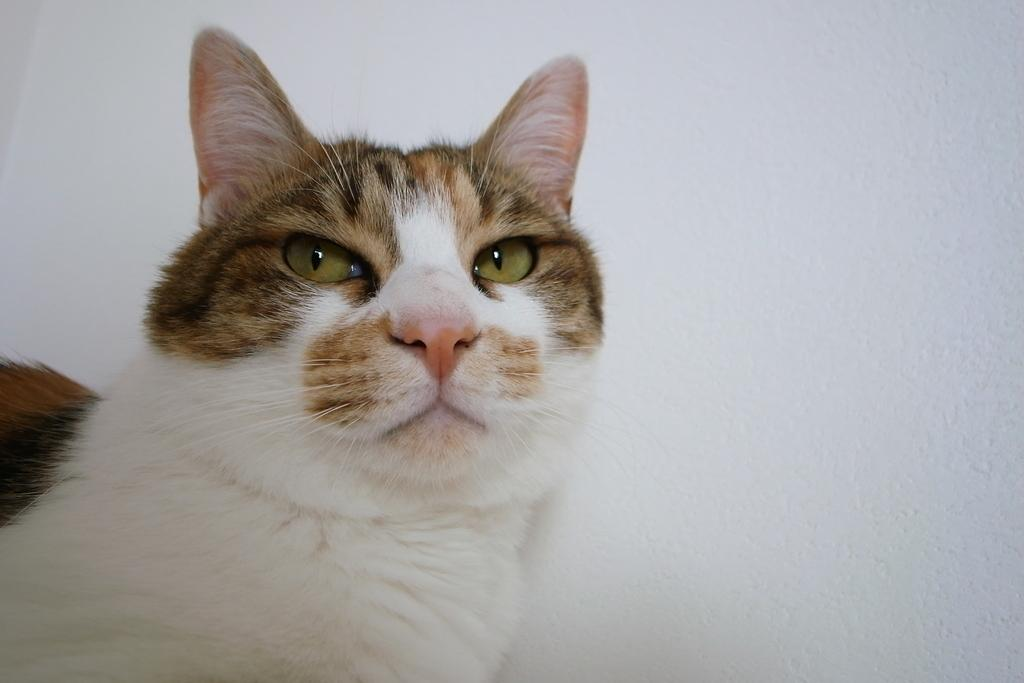What type of animal is present in the image? There is a cat in the image. What color or material is the surface that the cat is on? There is a white surface in the image. What type of wine is being served on the wooden table in the image? There is no wooden table or wine present in the image; it only features a cat on a white surface. 